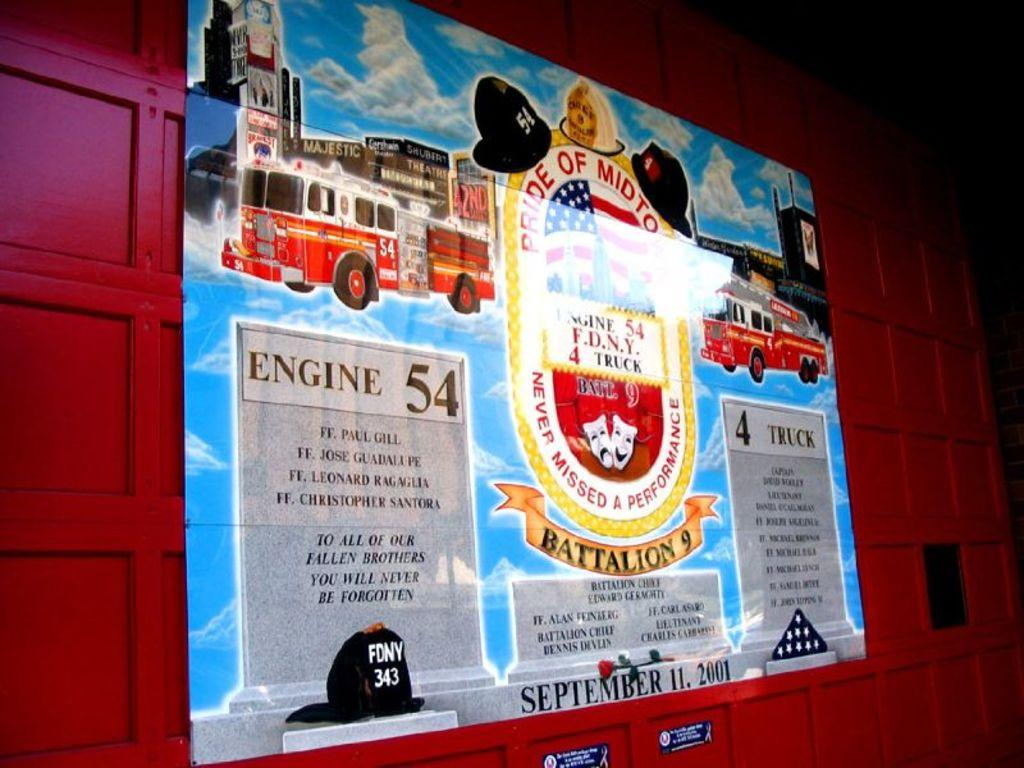<image>
Give a short and clear explanation of the subsequent image. a banner on a wall that says 'engine 54' on it 